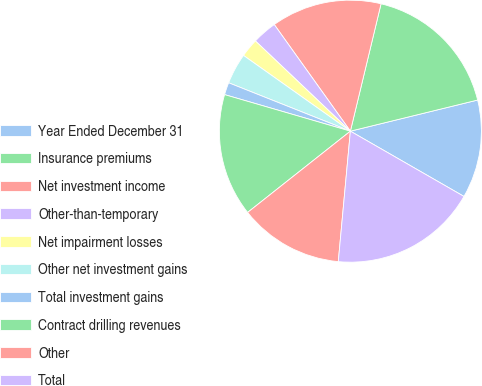Convert chart to OTSL. <chart><loc_0><loc_0><loc_500><loc_500><pie_chart><fcel>Year Ended December 31<fcel>Insurance premiums<fcel>Net investment income<fcel>Other-than-temporary<fcel>Net impairment losses<fcel>Other net investment gains<fcel>Total investment gains<fcel>Contract drilling revenues<fcel>Other<fcel>Total<nl><fcel>12.12%<fcel>17.42%<fcel>13.63%<fcel>3.04%<fcel>2.28%<fcel>3.79%<fcel>1.52%<fcel>15.15%<fcel>12.88%<fcel>18.17%<nl></chart> 